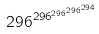Convert formula to latex. <formula><loc_0><loc_0><loc_500><loc_500>2 9 6 ^ { 2 9 6 ^ { 2 9 6 ^ { 2 9 6 ^ { 2 9 4 } } } }</formula> 